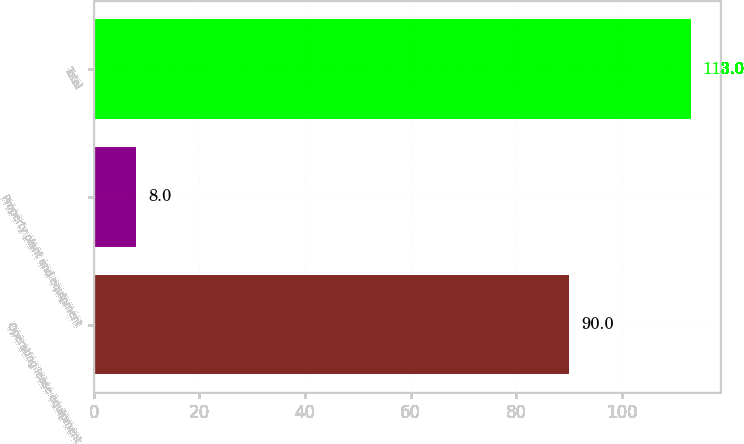Convert chart to OTSL. <chart><loc_0><loc_0><loc_500><loc_500><bar_chart><fcel>Operating lease equipment<fcel>Property plant and equipment<fcel>Total<nl><fcel>90<fcel>8<fcel>113<nl></chart> 